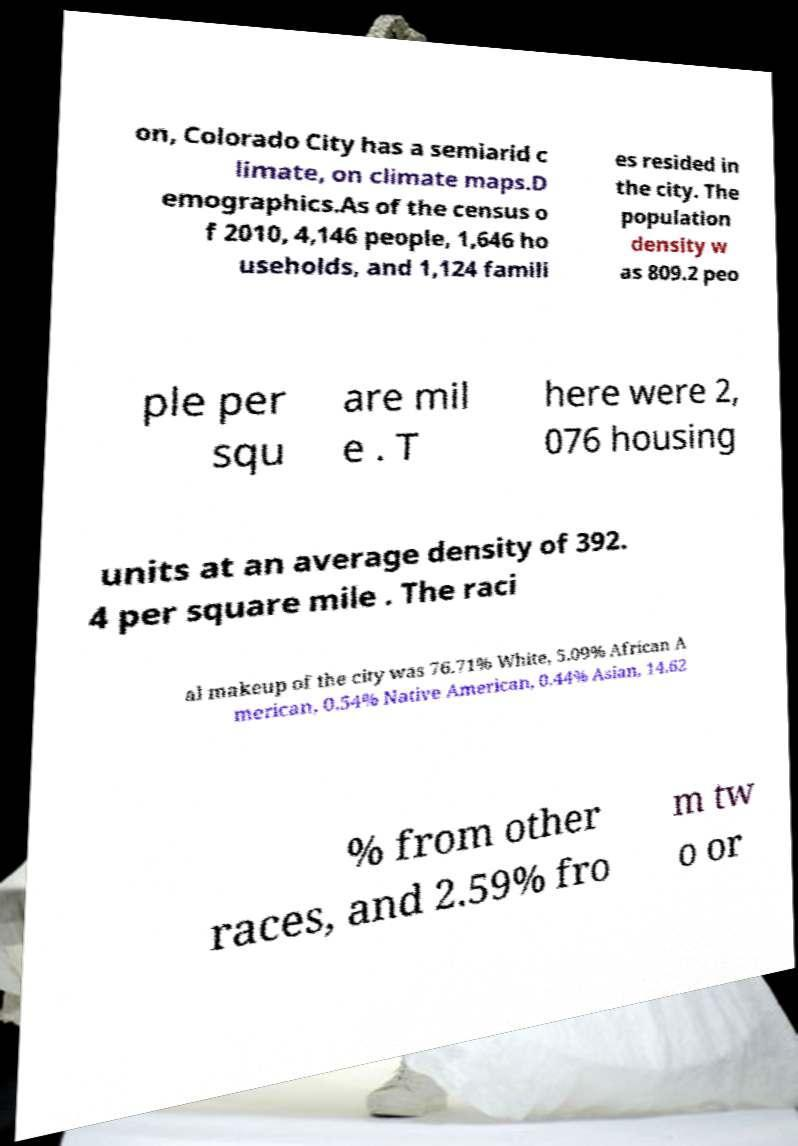I need the written content from this picture converted into text. Can you do that? on, Colorado City has a semiarid c limate, on climate maps.D emographics.As of the census o f 2010, 4,146 people, 1,646 ho useholds, and 1,124 famili es resided in the city. The population density w as 809.2 peo ple per squ are mil e . T here were 2, 076 housing units at an average density of 392. 4 per square mile . The raci al makeup of the city was 76.71% White, 5.09% African A merican, 0.54% Native American, 0.44% Asian, 14.62 % from other races, and 2.59% fro m tw o or 